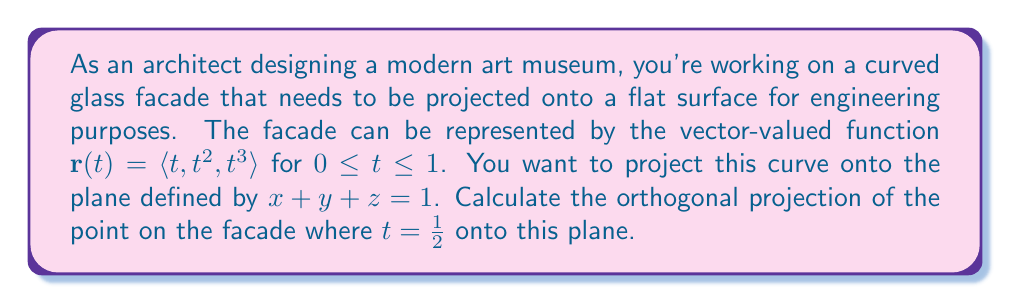Can you answer this question? Let's approach this step-by-step:

1) First, we need to find the normal vector of the plane $x + y + z = 1$. This is simply $\mathbf{n} = \langle 1, 1, 1 \rangle$.

2) Next, we need to find the point on the facade where $t = \frac{1}{2}$:

   $\mathbf{p} = \mathbf{r}(\frac{1}{2}) = \langle \frac{1}{2}, (\frac{1}{2})^2, (\frac{1}{2})^3 \rangle = \langle \frac{1}{2}, \frac{1}{4}, \frac{1}{8} \rangle$

3) Now, we need a point on the plane. We can use $\mathbf{q} = \langle 1, 0, 0 \rangle$ which satisfies the plane equation.

4) The vector from $\mathbf{q}$ to $\mathbf{p}$ is:

   $\mathbf{v} = \mathbf{p} - \mathbf{q} = \langle -\frac{1}{2}, \frac{1}{4}, \frac{1}{8} \rangle$

5) The orthogonal projection of $\mathbf{p}$ onto the plane is given by:

   $\text{proj}_\text{plane}(\mathbf{p}) = \mathbf{p} - \frac{\mathbf{v} \cdot \mathbf{n}}{\|\mathbf{n}\|^2} \mathbf{n}$

6) Let's calculate $\mathbf{v} \cdot \mathbf{n}$:

   $\mathbf{v} \cdot \mathbf{n} = (-\frac{1}{2})(1) + (\frac{1}{4})(1) + (\frac{1}{8})(1) = -\frac{1}{8}$

7) And $\|\mathbf{n}\|^2$:

   $\|\mathbf{n}\|^2 = 1^2 + 1^2 + 1^2 = 3$

8) Now we can calculate the projection:

   $\text{proj}_\text{plane}(\mathbf{p}) = \langle \frac{1}{2}, \frac{1}{4}, \frac{1}{8} \rangle - \frac{-\frac{1}{8}}{3} \langle 1, 1, 1 \rangle$

   $= \langle \frac{1}{2}, \frac{1}{4}, \frac{1}{8} \rangle + \langle \frac{1}{24}, \frac{1}{24}, \frac{1}{24} \rangle$

   $= \langle \frac{13}{24}, \frac{7}{24}, \frac{4}{24} \rangle$
Answer: The orthogonal projection of the point $\langle \frac{1}{2}, \frac{1}{4}, \frac{1}{8} \rangle$ onto the plane $x + y + z = 1$ is $\langle \frac{13}{24}, \frac{7}{24}, \frac{4}{24} \rangle$. 